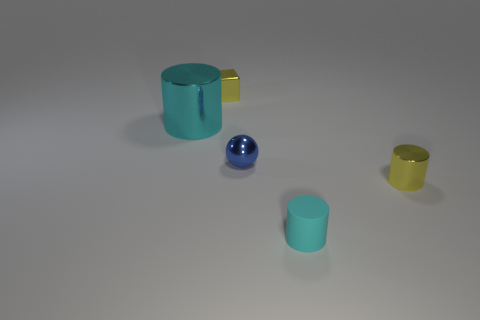There is a object that is the same color as the small matte cylinder; what is its size?
Your answer should be compact. Large. What number of other objects are there of the same color as the big thing?
Give a very brief answer. 1. The yellow metallic cylinder has what size?
Offer a very short reply. Small. Is the color of the metal cylinder to the right of the small blue sphere the same as the tiny metal thing behind the big cyan metal cylinder?
Give a very brief answer. Yes. What number of other things are the same material as the small cyan thing?
Your response must be concise. 0. Are any cyan objects visible?
Provide a short and direct response. Yes. Is the material of the yellow object that is left of the cyan matte cylinder the same as the ball?
Keep it short and to the point. Yes. There is a small yellow object that is the same shape as the cyan metallic object; what material is it?
Your answer should be compact. Metal. There is a thing that is the same color as the tiny matte cylinder; what material is it?
Provide a succinct answer. Metal. Are there fewer small blue balls than small brown shiny balls?
Provide a succinct answer. No. 